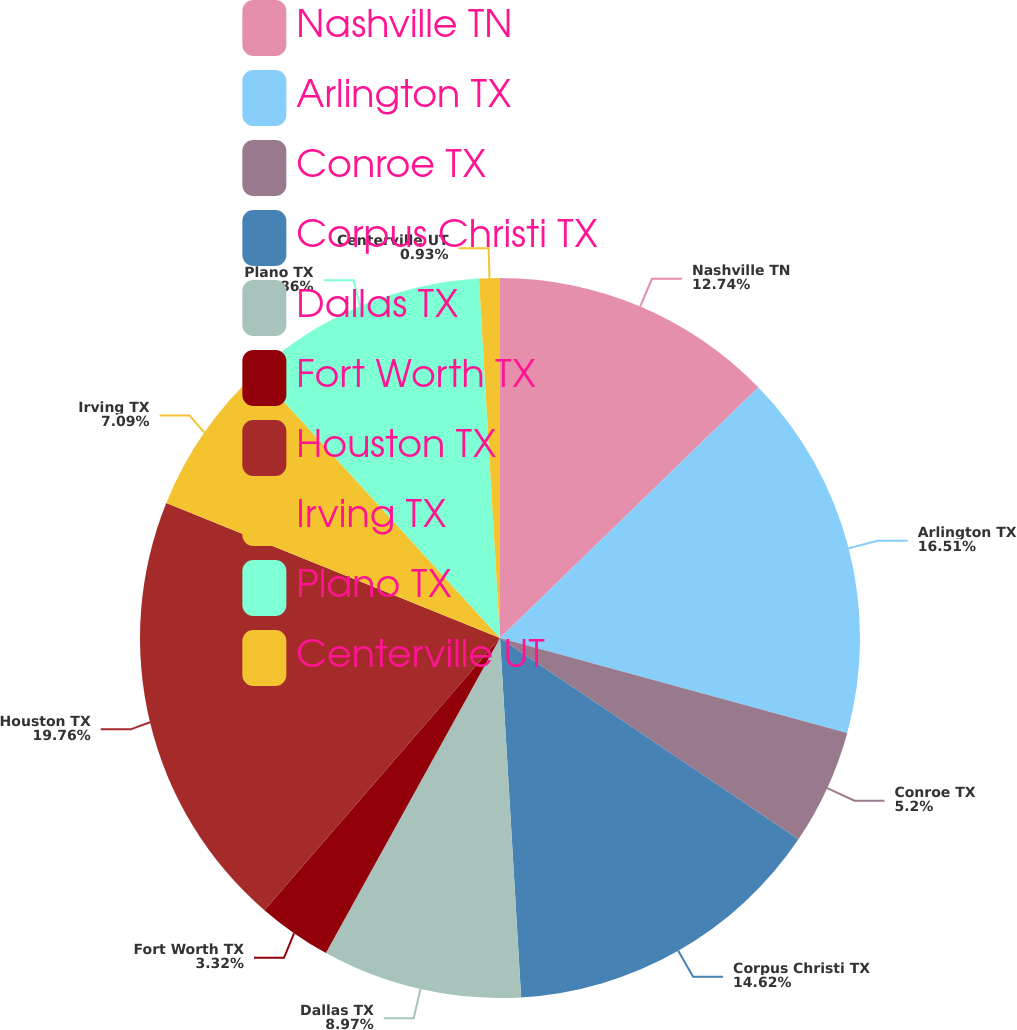<chart> <loc_0><loc_0><loc_500><loc_500><pie_chart><fcel>Nashville TN<fcel>Arlington TX<fcel>Conroe TX<fcel>Corpus Christi TX<fcel>Dallas TX<fcel>Fort Worth TX<fcel>Houston TX<fcel>Irving TX<fcel>Plano TX<fcel>Centerville UT<nl><fcel>12.74%<fcel>16.51%<fcel>5.2%<fcel>14.62%<fcel>8.97%<fcel>3.32%<fcel>19.77%<fcel>7.09%<fcel>10.86%<fcel>0.93%<nl></chart> 